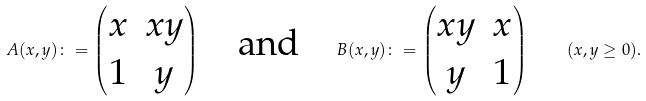Convert formula to latex. <formula><loc_0><loc_0><loc_500><loc_500>A ( x , y ) \colon = \begin{pmatrix} x & x y \\ 1 & y \end{pmatrix} \quad \text {and} \quad B ( x , y ) \colon = \begin{pmatrix} x y & x \\ y & 1 \end{pmatrix} \quad ( x , y \geq 0 ) .</formula> 